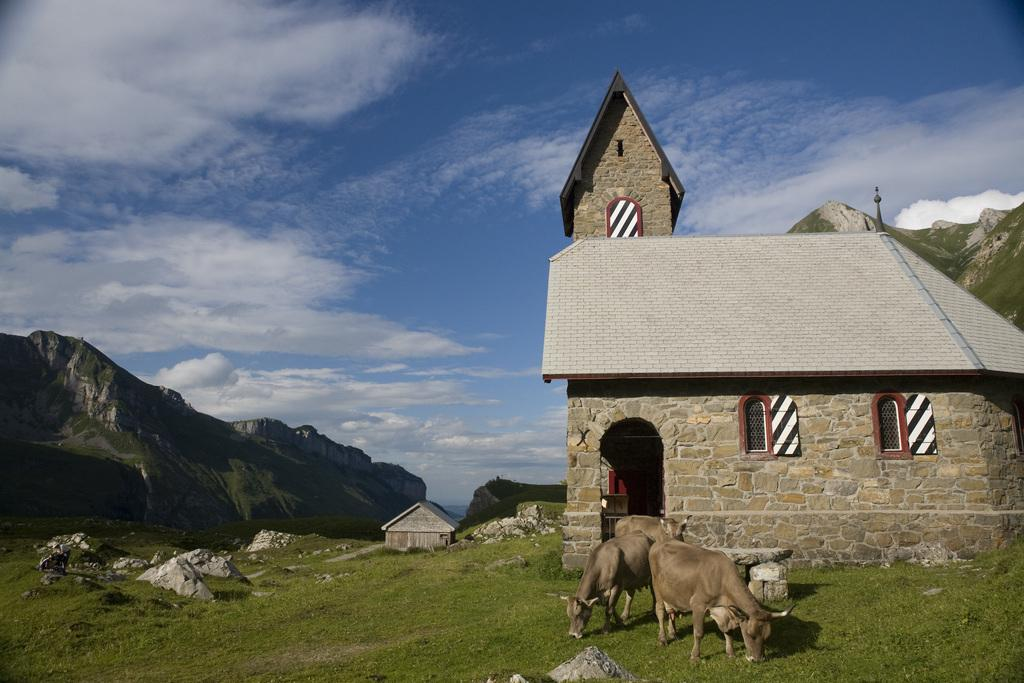What animals can be seen grazing at the bottom of the image? There are three cows grazing at the bottom of the image. What structure is located on the right side of the image? There is a house on the right side of the image. What type of landscape feature is on the left side of the image? There are hills on the left side of the image. What is visible at the top of the image? The sky is visible at the top of the image. Can you tell me where the drain is located in the image? There is no drain present in the image. Are the cows involved in a fight in the image? The cows are grazing peacefully and are not involved in a fight in the image. 